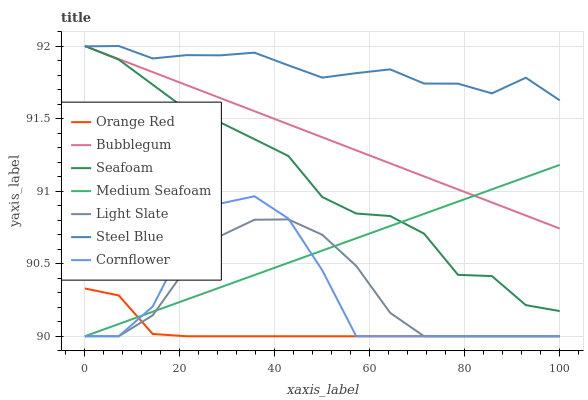Does Orange Red have the minimum area under the curve?
Answer yes or no. Yes. Does Steel Blue have the maximum area under the curve?
Answer yes or no. Yes. Does Seafoam have the minimum area under the curve?
Answer yes or no. No. Does Seafoam have the maximum area under the curve?
Answer yes or no. No. Is Medium Seafoam the smoothest?
Answer yes or no. Yes. Is Cornflower the roughest?
Answer yes or no. Yes. Is Seafoam the smoothest?
Answer yes or no. No. Is Seafoam the roughest?
Answer yes or no. No. Does Cornflower have the lowest value?
Answer yes or no. Yes. Does Seafoam have the lowest value?
Answer yes or no. No. Does Bubblegum have the highest value?
Answer yes or no. Yes. Does Light Slate have the highest value?
Answer yes or no. No. Is Orange Red less than Steel Blue?
Answer yes or no. Yes. Is Steel Blue greater than Medium Seafoam?
Answer yes or no. Yes. Does Cornflower intersect Light Slate?
Answer yes or no. Yes. Is Cornflower less than Light Slate?
Answer yes or no. No. Is Cornflower greater than Light Slate?
Answer yes or no. No. Does Orange Red intersect Steel Blue?
Answer yes or no. No. 